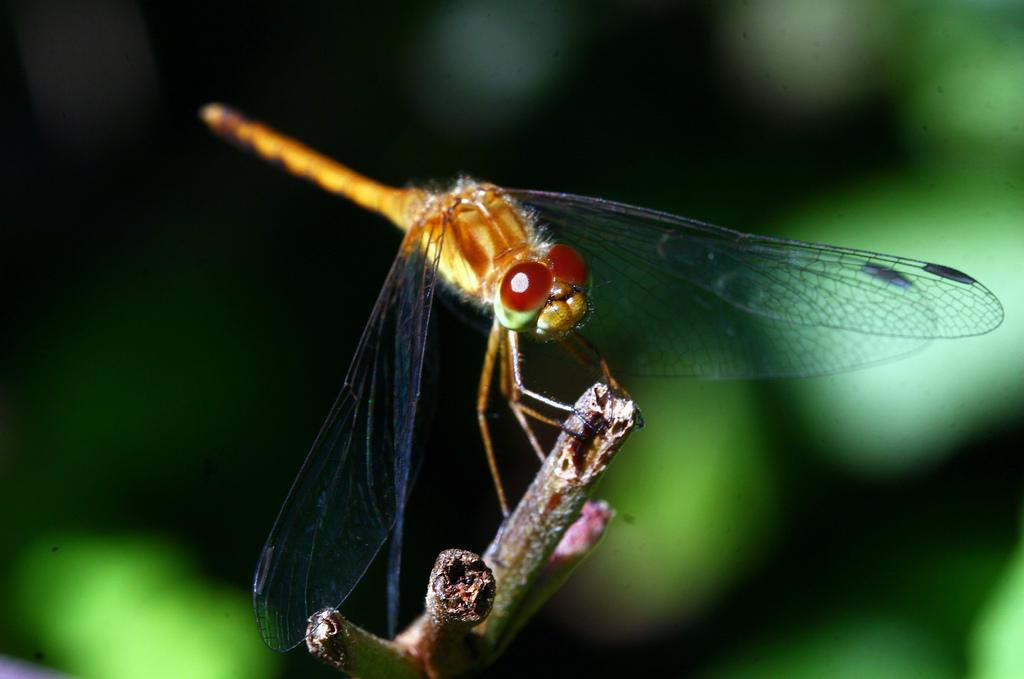What type of insect is in the image? There is a dragonfly in the image. What is the dragonfly standing on? The dragonfly is standing on a stem. Can you describe the background of the image? The background of the image is blurry. What type of lead can be seen in the image? There is no lead present in the image; it features a dragonfly standing on a stem with a blurry background. 